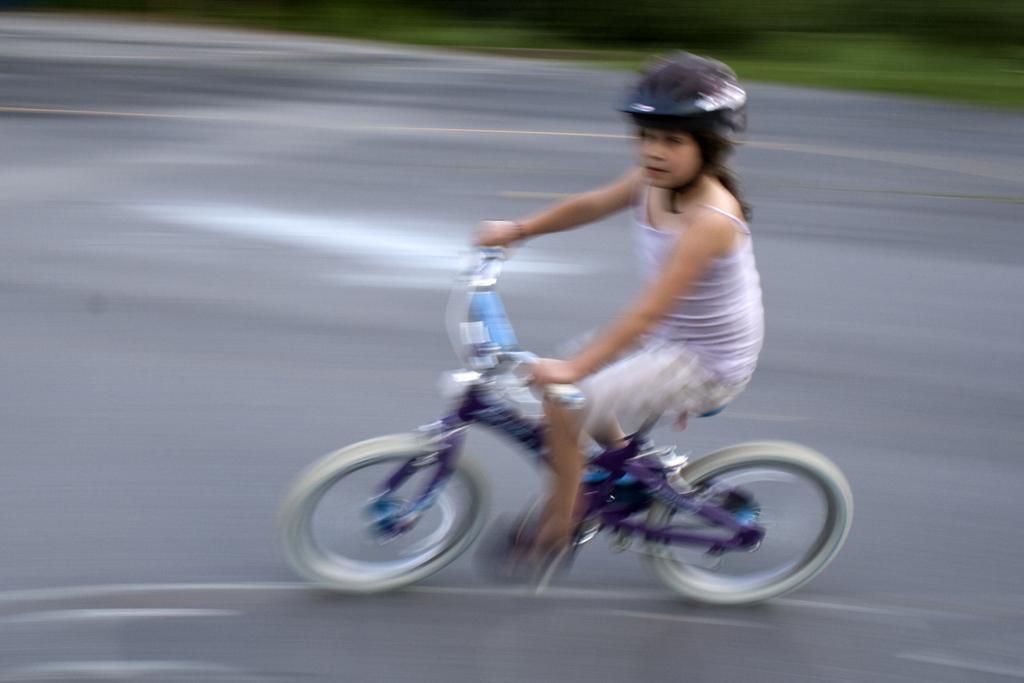How would you summarize this image in a sentence or two? In this Image I see a girl who is on the cycle and she is on the path. 